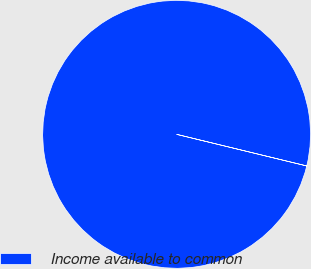Convert chart to OTSL. <chart><loc_0><loc_0><loc_500><loc_500><pie_chart><fcel>Income available to common<nl><fcel>100.0%<nl></chart> 